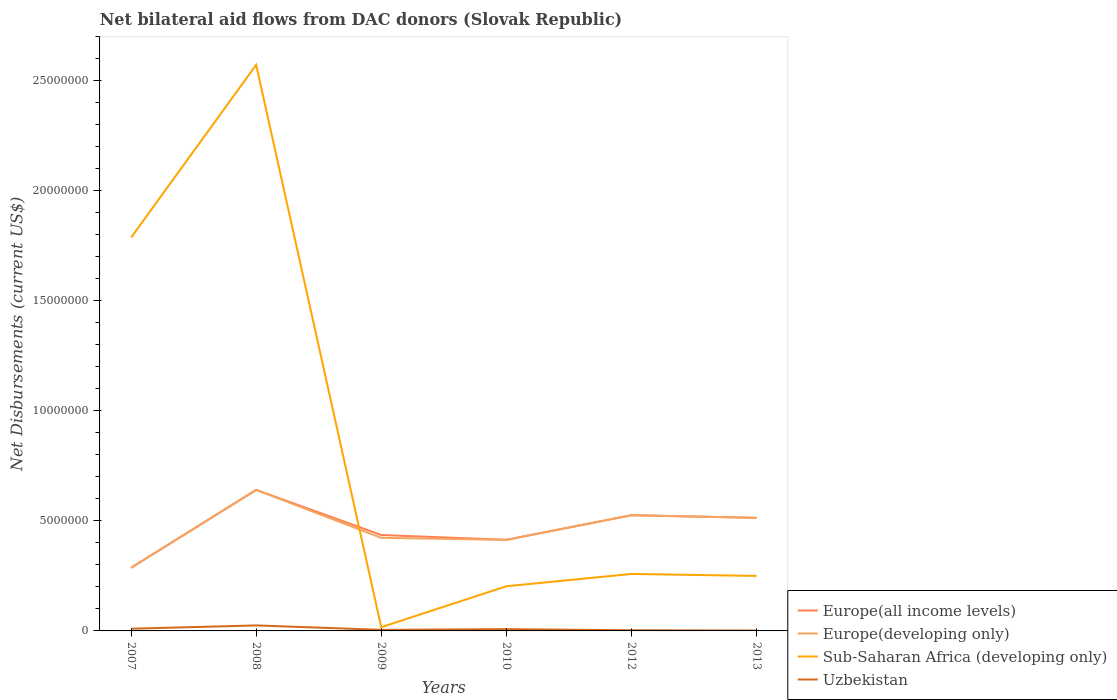How many different coloured lines are there?
Your answer should be compact. 4. Is the number of lines equal to the number of legend labels?
Your response must be concise. Yes. Across all years, what is the maximum net bilateral aid flows in Sub-Saharan Africa (developing only)?
Give a very brief answer. 1.70e+05. What is the difference between the highest and the second highest net bilateral aid flows in Europe(all income levels)?
Your answer should be very brief. 3.54e+06. What is the difference between the highest and the lowest net bilateral aid flows in Uzbekistan?
Offer a very short reply. 2. Is the net bilateral aid flows in Uzbekistan strictly greater than the net bilateral aid flows in Europe(developing only) over the years?
Offer a very short reply. Yes. How many lines are there?
Offer a very short reply. 4. What is the difference between two consecutive major ticks on the Y-axis?
Provide a short and direct response. 5.00e+06. Does the graph contain any zero values?
Give a very brief answer. No. What is the title of the graph?
Your response must be concise. Net bilateral aid flows from DAC donors (Slovak Republic). What is the label or title of the X-axis?
Keep it short and to the point. Years. What is the label or title of the Y-axis?
Your answer should be compact. Net Disbursements (current US$). What is the Net Disbursements (current US$) in Europe(all income levels) in 2007?
Provide a short and direct response. 2.87e+06. What is the Net Disbursements (current US$) of Europe(developing only) in 2007?
Keep it short and to the point. 2.87e+06. What is the Net Disbursements (current US$) of Sub-Saharan Africa (developing only) in 2007?
Give a very brief answer. 1.79e+07. What is the Net Disbursements (current US$) in Europe(all income levels) in 2008?
Ensure brevity in your answer.  6.41e+06. What is the Net Disbursements (current US$) in Europe(developing only) in 2008?
Ensure brevity in your answer.  6.41e+06. What is the Net Disbursements (current US$) in Sub-Saharan Africa (developing only) in 2008?
Offer a very short reply. 2.57e+07. What is the Net Disbursements (current US$) in Europe(all income levels) in 2009?
Offer a terse response. 4.36e+06. What is the Net Disbursements (current US$) of Europe(developing only) in 2009?
Provide a succinct answer. 4.23e+06. What is the Net Disbursements (current US$) in Europe(all income levels) in 2010?
Make the answer very short. 4.14e+06. What is the Net Disbursements (current US$) in Europe(developing only) in 2010?
Provide a short and direct response. 4.14e+06. What is the Net Disbursements (current US$) in Sub-Saharan Africa (developing only) in 2010?
Offer a very short reply. 2.03e+06. What is the Net Disbursements (current US$) of Uzbekistan in 2010?
Keep it short and to the point. 8.00e+04. What is the Net Disbursements (current US$) of Europe(all income levels) in 2012?
Offer a terse response. 5.26e+06. What is the Net Disbursements (current US$) in Europe(developing only) in 2012?
Provide a short and direct response. 5.26e+06. What is the Net Disbursements (current US$) in Sub-Saharan Africa (developing only) in 2012?
Give a very brief answer. 2.59e+06. What is the Net Disbursements (current US$) of Uzbekistan in 2012?
Offer a very short reply. 3.00e+04. What is the Net Disbursements (current US$) of Europe(all income levels) in 2013?
Ensure brevity in your answer.  5.14e+06. What is the Net Disbursements (current US$) in Europe(developing only) in 2013?
Your response must be concise. 5.14e+06. What is the Net Disbursements (current US$) of Sub-Saharan Africa (developing only) in 2013?
Ensure brevity in your answer.  2.50e+06. Across all years, what is the maximum Net Disbursements (current US$) of Europe(all income levels)?
Offer a very short reply. 6.41e+06. Across all years, what is the maximum Net Disbursements (current US$) in Europe(developing only)?
Provide a succinct answer. 6.41e+06. Across all years, what is the maximum Net Disbursements (current US$) of Sub-Saharan Africa (developing only)?
Offer a terse response. 2.57e+07. Across all years, what is the minimum Net Disbursements (current US$) of Europe(all income levels)?
Ensure brevity in your answer.  2.87e+06. Across all years, what is the minimum Net Disbursements (current US$) of Europe(developing only)?
Offer a very short reply. 2.87e+06. What is the total Net Disbursements (current US$) in Europe(all income levels) in the graph?
Your answer should be compact. 2.82e+07. What is the total Net Disbursements (current US$) in Europe(developing only) in the graph?
Your answer should be very brief. 2.80e+07. What is the total Net Disbursements (current US$) of Sub-Saharan Africa (developing only) in the graph?
Give a very brief answer. 5.09e+07. What is the total Net Disbursements (current US$) of Uzbekistan in the graph?
Provide a succinct answer. 5.30e+05. What is the difference between the Net Disbursements (current US$) in Europe(all income levels) in 2007 and that in 2008?
Your answer should be compact. -3.54e+06. What is the difference between the Net Disbursements (current US$) of Europe(developing only) in 2007 and that in 2008?
Keep it short and to the point. -3.54e+06. What is the difference between the Net Disbursements (current US$) of Sub-Saharan Africa (developing only) in 2007 and that in 2008?
Provide a short and direct response. -7.85e+06. What is the difference between the Net Disbursements (current US$) in Europe(all income levels) in 2007 and that in 2009?
Make the answer very short. -1.49e+06. What is the difference between the Net Disbursements (current US$) in Europe(developing only) in 2007 and that in 2009?
Provide a short and direct response. -1.36e+06. What is the difference between the Net Disbursements (current US$) in Sub-Saharan Africa (developing only) in 2007 and that in 2009?
Provide a succinct answer. 1.77e+07. What is the difference between the Net Disbursements (current US$) of Europe(all income levels) in 2007 and that in 2010?
Offer a very short reply. -1.27e+06. What is the difference between the Net Disbursements (current US$) in Europe(developing only) in 2007 and that in 2010?
Offer a terse response. -1.27e+06. What is the difference between the Net Disbursements (current US$) of Sub-Saharan Africa (developing only) in 2007 and that in 2010?
Your answer should be very brief. 1.58e+07. What is the difference between the Net Disbursements (current US$) of Europe(all income levels) in 2007 and that in 2012?
Offer a very short reply. -2.39e+06. What is the difference between the Net Disbursements (current US$) of Europe(developing only) in 2007 and that in 2012?
Provide a short and direct response. -2.39e+06. What is the difference between the Net Disbursements (current US$) of Sub-Saharan Africa (developing only) in 2007 and that in 2012?
Your answer should be very brief. 1.53e+07. What is the difference between the Net Disbursements (current US$) in Uzbekistan in 2007 and that in 2012?
Ensure brevity in your answer.  7.00e+04. What is the difference between the Net Disbursements (current US$) of Europe(all income levels) in 2007 and that in 2013?
Provide a succinct answer. -2.27e+06. What is the difference between the Net Disbursements (current US$) in Europe(developing only) in 2007 and that in 2013?
Your response must be concise. -2.27e+06. What is the difference between the Net Disbursements (current US$) in Sub-Saharan Africa (developing only) in 2007 and that in 2013?
Offer a terse response. 1.54e+07. What is the difference between the Net Disbursements (current US$) in Uzbekistan in 2007 and that in 2013?
Make the answer very short. 8.00e+04. What is the difference between the Net Disbursements (current US$) in Europe(all income levels) in 2008 and that in 2009?
Keep it short and to the point. 2.05e+06. What is the difference between the Net Disbursements (current US$) in Europe(developing only) in 2008 and that in 2009?
Provide a succinct answer. 2.18e+06. What is the difference between the Net Disbursements (current US$) of Sub-Saharan Africa (developing only) in 2008 and that in 2009?
Make the answer very short. 2.56e+07. What is the difference between the Net Disbursements (current US$) in Uzbekistan in 2008 and that in 2009?
Provide a succinct answer. 2.00e+05. What is the difference between the Net Disbursements (current US$) in Europe(all income levels) in 2008 and that in 2010?
Offer a very short reply. 2.27e+06. What is the difference between the Net Disbursements (current US$) in Europe(developing only) in 2008 and that in 2010?
Your response must be concise. 2.27e+06. What is the difference between the Net Disbursements (current US$) of Sub-Saharan Africa (developing only) in 2008 and that in 2010?
Ensure brevity in your answer.  2.37e+07. What is the difference between the Net Disbursements (current US$) in Uzbekistan in 2008 and that in 2010?
Ensure brevity in your answer.  1.70e+05. What is the difference between the Net Disbursements (current US$) in Europe(all income levels) in 2008 and that in 2012?
Provide a succinct answer. 1.15e+06. What is the difference between the Net Disbursements (current US$) in Europe(developing only) in 2008 and that in 2012?
Offer a very short reply. 1.15e+06. What is the difference between the Net Disbursements (current US$) in Sub-Saharan Africa (developing only) in 2008 and that in 2012?
Your answer should be very brief. 2.31e+07. What is the difference between the Net Disbursements (current US$) in Uzbekistan in 2008 and that in 2012?
Keep it short and to the point. 2.20e+05. What is the difference between the Net Disbursements (current US$) of Europe(all income levels) in 2008 and that in 2013?
Make the answer very short. 1.27e+06. What is the difference between the Net Disbursements (current US$) in Europe(developing only) in 2008 and that in 2013?
Make the answer very short. 1.27e+06. What is the difference between the Net Disbursements (current US$) of Sub-Saharan Africa (developing only) in 2008 and that in 2013?
Offer a very short reply. 2.32e+07. What is the difference between the Net Disbursements (current US$) in Uzbekistan in 2008 and that in 2013?
Keep it short and to the point. 2.30e+05. What is the difference between the Net Disbursements (current US$) in Europe(developing only) in 2009 and that in 2010?
Your response must be concise. 9.00e+04. What is the difference between the Net Disbursements (current US$) of Sub-Saharan Africa (developing only) in 2009 and that in 2010?
Your answer should be very brief. -1.86e+06. What is the difference between the Net Disbursements (current US$) in Europe(all income levels) in 2009 and that in 2012?
Offer a terse response. -9.00e+05. What is the difference between the Net Disbursements (current US$) in Europe(developing only) in 2009 and that in 2012?
Provide a succinct answer. -1.03e+06. What is the difference between the Net Disbursements (current US$) in Sub-Saharan Africa (developing only) in 2009 and that in 2012?
Make the answer very short. -2.42e+06. What is the difference between the Net Disbursements (current US$) of Europe(all income levels) in 2009 and that in 2013?
Offer a very short reply. -7.80e+05. What is the difference between the Net Disbursements (current US$) in Europe(developing only) in 2009 and that in 2013?
Your response must be concise. -9.10e+05. What is the difference between the Net Disbursements (current US$) in Sub-Saharan Africa (developing only) in 2009 and that in 2013?
Your answer should be very brief. -2.33e+06. What is the difference between the Net Disbursements (current US$) of Europe(all income levels) in 2010 and that in 2012?
Provide a short and direct response. -1.12e+06. What is the difference between the Net Disbursements (current US$) in Europe(developing only) in 2010 and that in 2012?
Offer a very short reply. -1.12e+06. What is the difference between the Net Disbursements (current US$) of Sub-Saharan Africa (developing only) in 2010 and that in 2012?
Offer a very short reply. -5.60e+05. What is the difference between the Net Disbursements (current US$) in Europe(all income levels) in 2010 and that in 2013?
Offer a very short reply. -1.00e+06. What is the difference between the Net Disbursements (current US$) of Europe(developing only) in 2010 and that in 2013?
Provide a succinct answer. -1.00e+06. What is the difference between the Net Disbursements (current US$) of Sub-Saharan Africa (developing only) in 2010 and that in 2013?
Your answer should be compact. -4.70e+05. What is the difference between the Net Disbursements (current US$) in Europe(developing only) in 2012 and that in 2013?
Offer a very short reply. 1.20e+05. What is the difference between the Net Disbursements (current US$) in Sub-Saharan Africa (developing only) in 2012 and that in 2013?
Offer a very short reply. 9.00e+04. What is the difference between the Net Disbursements (current US$) of Uzbekistan in 2012 and that in 2013?
Make the answer very short. 10000. What is the difference between the Net Disbursements (current US$) in Europe(all income levels) in 2007 and the Net Disbursements (current US$) in Europe(developing only) in 2008?
Your response must be concise. -3.54e+06. What is the difference between the Net Disbursements (current US$) of Europe(all income levels) in 2007 and the Net Disbursements (current US$) of Sub-Saharan Africa (developing only) in 2008?
Your answer should be very brief. -2.29e+07. What is the difference between the Net Disbursements (current US$) of Europe(all income levels) in 2007 and the Net Disbursements (current US$) of Uzbekistan in 2008?
Offer a terse response. 2.62e+06. What is the difference between the Net Disbursements (current US$) of Europe(developing only) in 2007 and the Net Disbursements (current US$) of Sub-Saharan Africa (developing only) in 2008?
Your response must be concise. -2.29e+07. What is the difference between the Net Disbursements (current US$) of Europe(developing only) in 2007 and the Net Disbursements (current US$) of Uzbekistan in 2008?
Your answer should be very brief. 2.62e+06. What is the difference between the Net Disbursements (current US$) in Sub-Saharan Africa (developing only) in 2007 and the Net Disbursements (current US$) in Uzbekistan in 2008?
Offer a very short reply. 1.76e+07. What is the difference between the Net Disbursements (current US$) of Europe(all income levels) in 2007 and the Net Disbursements (current US$) of Europe(developing only) in 2009?
Provide a succinct answer. -1.36e+06. What is the difference between the Net Disbursements (current US$) of Europe(all income levels) in 2007 and the Net Disbursements (current US$) of Sub-Saharan Africa (developing only) in 2009?
Make the answer very short. 2.70e+06. What is the difference between the Net Disbursements (current US$) in Europe(all income levels) in 2007 and the Net Disbursements (current US$) in Uzbekistan in 2009?
Make the answer very short. 2.82e+06. What is the difference between the Net Disbursements (current US$) in Europe(developing only) in 2007 and the Net Disbursements (current US$) in Sub-Saharan Africa (developing only) in 2009?
Offer a very short reply. 2.70e+06. What is the difference between the Net Disbursements (current US$) of Europe(developing only) in 2007 and the Net Disbursements (current US$) of Uzbekistan in 2009?
Give a very brief answer. 2.82e+06. What is the difference between the Net Disbursements (current US$) of Sub-Saharan Africa (developing only) in 2007 and the Net Disbursements (current US$) of Uzbekistan in 2009?
Your answer should be very brief. 1.78e+07. What is the difference between the Net Disbursements (current US$) in Europe(all income levels) in 2007 and the Net Disbursements (current US$) in Europe(developing only) in 2010?
Your response must be concise. -1.27e+06. What is the difference between the Net Disbursements (current US$) of Europe(all income levels) in 2007 and the Net Disbursements (current US$) of Sub-Saharan Africa (developing only) in 2010?
Offer a terse response. 8.40e+05. What is the difference between the Net Disbursements (current US$) of Europe(all income levels) in 2007 and the Net Disbursements (current US$) of Uzbekistan in 2010?
Your answer should be very brief. 2.79e+06. What is the difference between the Net Disbursements (current US$) of Europe(developing only) in 2007 and the Net Disbursements (current US$) of Sub-Saharan Africa (developing only) in 2010?
Provide a short and direct response. 8.40e+05. What is the difference between the Net Disbursements (current US$) of Europe(developing only) in 2007 and the Net Disbursements (current US$) of Uzbekistan in 2010?
Provide a succinct answer. 2.79e+06. What is the difference between the Net Disbursements (current US$) in Sub-Saharan Africa (developing only) in 2007 and the Net Disbursements (current US$) in Uzbekistan in 2010?
Ensure brevity in your answer.  1.78e+07. What is the difference between the Net Disbursements (current US$) of Europe(all income levels) in 2007 and the Net Disbursements (current US$) of Europe(developing only) in 2012?
Your answer should be compact. -2.39e+06. What is the difference between the Net Disbursements (current US$) in Europe(all income levels) in 2007 and the Net Disbursements (current US$) in Sub-Saharan Africa (developing only) in 2012?
Keep it short and to the point. 2.80e+05. What is the difference between the Net Disbursements (current US$) in Europe(all income levels) in 2007 and the Net Disbursements (current US$) in Uzbekistan in 2012?
Offer a terse response. 2.84e+06. What is the difference between the Net Disbursements (current US$) in Europe(developing only) in 2007 and the Net Disbursements (current US$) in Sub-Saharan Africa (developing only) in 2012?
Keep it short and to the point. 2.80e+05. What is the difference between the Net Disbursements (current US$) of Europe(developing only) in 2007 and the Net Disbursements (current US$) of Uzbekistan in 2012?
Your response must be concise. 2.84e+06. What is the difference between the Net Disbursements (current US$) in Sub-Saharan Africa (developing only) in 2007 and the Net Disbursements (current US$) in Uzbekistan in 2012?
Your answer should be compact. 1.78e+07. What is the difference between the Net Disbursements (current US$) in Europe(all income levels) in 2007 and the Net Disbursements (current US$) in Europe(developing only) in 2013?
Make the answer very short. -2.27e+06. What is the difference between the Net Disbursements (current US$) of Europe(all income levels) in 2007 and the Net Disbursements (current US$) of Sub-Saharan Africa (developing only) in 2013?
Offer a very short reply. 3.70e+05. What is the difference between the Net Disbursements (current US$) in Europe(all income levels) in 2007 and the Net Disbursements (current US$) in Uzbekistan in 2013?
Ensure brevity in your answer.  2.85e+06. What is the difference between the Net Disbursements (current US$) of Europe(developing only) in 2007 and the Net Disbursements (current US$) of Sub-Saharan Africa (developing only) in 2013?
Ensure brevity in your answer.  3.70e+05. What is the difference between the Net Disbursements (current US$) of Europe(developing only) in 2007 and the Net Disbursements (current US$) of Uzbekistan in 2013?
Keep it short and to the point. 2.85e+06. What is the difference between the Net Disbursements (current US$) of Sub-Saharan Africa (developing only) in 2007 and the Net Disbursements (current US$) of Uzbekistan in 2013?
Your answer should be compact. 1.79e+07. What is the difference between the Net Disbursements (current US$) of Europe(all income levels) in 2008 and the Net Disbursements (current US$) of Europe(developing only) in 2009?
Give a very brief answer. 2.18e+06. What is the difference between the Net Disbursements (current US$) in Europe(all income levels) in 2008 and the Net Disbursements (current US$) in Sub-Saharan Africa (developing only) in 2009?
Your answer should be very brief. 6.24e+06. What is the difference between the Net Disbursements (current US$) in Europe(all income levels) in 2008 and the Net Disbursements (current US$) in Uzbekistan in 2009?
Your answer should be compact. 6.36e+06. What is the difference between the Net Disbursements (current US$) in Europe(developing only) in 2008 and the Net Disbursements (current US$) in Sub-Saharan Africa (developing only) in 2009?
Provide a succinct answer. 6.24e+06. What is the difference between the Net Disbursements (current US$) in Europe(developing only) in 2008 and the Net Disbursements (current US$) in Uzbekistan in 2009?
Provide a succinct answer. 6.36e+06. What is the difference between the Net Disbursements (current US$) of Sub-Saharan Africa (developing only) in 2008 and the Net Disbursements (current US$) of Uzbekistan in 2009?
Give a very brief answer. 2.57e+07. What is the difference between the Net Disbursements (current US$) in Europe(all income levels) in 2008 and the Net Disbursements (current US$) in Europe(developing only) in 2010?
Your answer should be very brief. 2.27e+06. What is the difference between the Net Disbursements (current US$) in Europe(all income levels) in 2008 and the Net Disbursements (current US$) in Sub-Saharan Africa (developing only) in 2010?
Give a very brief answer. 4.38e+06. What is the difference between the Net Disbursements (current US$) in Europe(all income levels) in 2008 and the Net Disbursements (current US$) in Uzbekistan in 2010?
Your response must be concise. 6.33e+06. What is the difference between the Net Disbursements (current US$) in Europe(developing only) in 2008 and the Net Disbursements (current US$) in Sub-Saharan Africa (developing only) in 2010?
Offer a very short reply. 4.38e+06. What is the difference between the Net Disbursements (current US$) of Europe(developing only) in 2008 and the Net Disbursements (current US$) of Uzbekistan in 2010?
Keep it short and to the point. 6.33e+06. What is the difference between the Net Disbursements (current US$) of Sub-Saharan Africa (developing only) in 2008 and the Net Disbursements (current US$) of Uzbekistan in 2010?
Keep it short and to the point. 2.56e+07. What is the difference between the Net Disbursements (current US$) of Europe(all income levels) in 2008 and the Net Disbursements (current US$) of Europe(developing only) in 2012?
Make the answer very short. 1.15e+06. What is the difference between the Net Disbursements (current US$) of Europe(all income levels) in 2008 and the Net Disbursements (current US$) of Sub-Saharan Africa (developing only) in 2012?
Keep it short and to the point. 3.82e+06. What is the difference between the Net Disbursements (current US$) of Europe(all income levels) in 2008 and the Net Disbursements (current US$) of Uzbekistan in 2012?
Your answer should be very brief. 6.38e+06. What is the difference between the Net Disbursements (current US$) of Europe(developing only) in 2008 and the Net Disbursements (current US$) of Sub-Saharan Africa (developing only) in 2012?
Keep it short and to the point. 3.82e+06. What is the difference between the Net Disbursements (current US$) of Europe(developing only) in 2008 and the Net Disbursements (current US$) of Uzbekistan in 2012?
Ensure brevity in your answer.  6.38e+06. What is the difference between the Net Disbursements (current US$) of Sub-Saharan Africa (developing only) in 2008 and the Net Disbursements (current US$) of Uzbekistan in 2012?
Make the answer very short. 2.57e+07. What is the difference between the Net Disbursements (current US$) in Europe(all income levels) in 2008 and the Net Disbursements (current US$) in Europe(developing only) in 2013?
Ensure brevity in your answer.  1.27e+06. What is the difference between the Net Disbursements (current US$) in Europe(all income levels) in 2008 and the Net Disbursements (current US$) in Sub-Saharan Africa (developing only) in 2013?
Make the answer very short. 3.91e+06. What is the difference between the Net Disbursements (current US$) of Europe(all income levels) in 2008 and the Net Disbursements (current US$) of Uzbekistan in 2013?
Your response must be concise. 6.39e+06. What is the difference between the Net Disbursements (current US$) of Europe(developing only) in 2008 and the Net Disbursements (current US$) of Sub-Saharan Africa (developing only) in 2013?
Offer a very short reply. 3.91e+06. What is the difference between the Net Disbursements (current US$) of Europe(developing only) in 2008 and the Net Disbursements (current US$) of Uzbekistan in 2013?
Give a very brief answer. 6.39e+06. What is the difference between the Net Disbursements (current US$) of Sub-Saharan Africa (developing only) in 2008 and the Net Disbursements (current US$) of Uzbekistan in 2013?
Give a very brief answer. 2.57e+07. What is the difference between the Net Disbursements (current US$) in Europe(all income levels) in 2009 and the Net Disbursements (current US$) in Europe(developing only) in 2010?
Offer a very short reply. 2.20e+05. What is the difference between the Net Disbursements (current US$) of Europe(all income levels) in 2009 and the Net Disbursements (current US$) of Sub-Saharan Africa (developing only) in 2010?
Provide a short and direct response. 2.33e+06. What is the difference between the Net Disbursements (current US$) in Europe(all income levels) in 2009 and the Net Disbursements (current US$) in Uzbekistan in 2010?
Your response must be concise. 4.28e+06. What is the difference between the Net Disbursements (current US$) in Europe(developing only) in 2009 and the Net Disbursements (current US$) in Sub-Saharan Africa (developing only) in 2010?
Give a very brief answer. 2.20e+06. What is the difference between the Net Disbursements (current US$) of Europe(developing only) in 2009 and the Net Disbursements (current US$) of Uzbekistan in 2010?
Provide a short and direct response. 4.15e+06. What is the difference between the Net Disbursements (current US$) of Sub-Saharan Africa (developing only) in 2009 and the Net Disbursements (current US$) of Uzbekistan in 2010?
Offer a very short reply. 9.00e+04. What is the difference between the Net Disbursements (current US$) in Europe(all income levels) in 2009 and the Net Disbursements (current US$) in Europe(developing only) in 2012?
Give a very brief answer. -9.00e+05. What is the difference between the Net Disbursements (current US$) in Europe(all income levels) in 2009 and the Net Disbursements (current US$) in Sub-Saharan Africa (developing only) in 2012?
Offer a terse response. 1.77e+06. What is the difference between the Net Disbursements (current US$) of Europe(all income levels) in 2009 and the Net Disbursements (current US$) of Uzbekistan in 2012?
Make the answer very short. 4.33e+06. What is the difference between the Net Disbursements (current US$) of Europe(developing only) in 2009 and the Net Disbursements (current US$) of Sub-Saharan Africa (developing only) in 2012?
Make the answer very short. 1.64e+06. What is the difference between the Net Disbursements (current US$) of Europe(developing only) in 2009 and the Net Disbursements (current US$) of Uzbekistan in 2012?
Offer a terse response. 4.20e+06. What is the difference between the Net Disbursements (current US$) in Sub-Saharan Africa (developing only) in 2009 and the Net Disbursements (current US$) in Uzbekistan in 2012?
Ensure brevity in your answer.  1.40e+05. What is the difference between the Net Disbursements (current US$) in Europe(all income levels) in 2009 and the Net Disbursements (current US$) in Europe(developing only) in 2013?
Your answer should be very brief. -7.80e+05. What is the difference between the Net Disbursements (current US$) in Europe(all income levels) in 2009 and the Net Disbursements (current US$) in Sub-Saharan Africa (developing only) in 2013?
Provide a short and direct response. 1.86e+06. What is the difference between the Net Disbursements (current US$) of Europe(all income levels) in 2009 and the Net Disbursements (current US$) of Uzbekistan in 2013?
Ensure brevity in your answer.  4.34e+06. What is the difference between the Net Disbursements (current US$) of Europe(developing only) in 2009 and the Net Disbursements (current US$) of Sub-Saharan Africa (developing only) in 2013?
Keep it short and to the point. 1.73e+06. What is the difference between the Net Disbursements (current US$) of Europe(developing only) in 2009 and the Net Disbursements (current US$) of Uzbekistan in 2013?
Provide a succinct answer. 4.21e+06. What is the difference between the Net Disbursements (current US$) in Europe(all income levels) in 2010 and the Net Disbursements (current US$) in Europe(developing only) in 2012?
Your answer should be compact. -1.12e+06. What is the difference between the Net Disbursements (current US$) of Europe(all income levels) in 2010 and the Net Disbursements (current US$) of Sub-Saharan Africa (developing only) in 2012?
Provide a succinct answer. 1.55e+06. What is the difference between the Net Disbursements (current US$) of Europe(all income levels) in 2010 and the Net Disbursements (current US$) of Uzbekistan in 2012?
Make the answer very short. 4.11e+06. What is the difference between the Net Disbursements (current US$) of Europe(developing only) in 2010 and the Net Disbursements (current US$) of Sub-Saharan Africa (developing only) in 2012?
Make the answer very short. 1.55e+06. What is the difference between the Net Disbursements (current US$) of Europe(developing only) in 2010 and the Net Disbursements (current US$) of Uzbekistan in 2012?
Offer a terse response. 4.11e+06. What is the difference between the Net Disbursements (current US$) of Sub-Saharan Africa (developing only) in 2010 and the Net Disbursements (current US$) of Uzbekistan in 2012?
Provide a succinct answer. 2.00e+06. What is the difference between the Net Disbursements (current US$) in Europe(all income levels) in 2010 and the Net Disbursements (current US$) in Sub-Saharan Africa (developing only) in 2013?
Make the answer very short. 1.64e+06. What is the difference between the Net Disbursements (current US$) in Europe(all income levels) in 2010 and the Net Disbursements (current US$) in Uzbekistan in 2013?
Your response must be concise. 4.12e+06. What is the difference between the Net Disbursements (current US$) of Europe(developing only) in 2010 and the Net Disbursements (current US$) of Sub-Saharan Africa (developing only) in 2013?
Ensure brevity in your answer.  1.64e+06. What is the difference between the Net Disbursements (current US$) in Europe(developing only) in 2010 and the Net Disbursements (current US$) in Uzbekistan in 2013?
Provide a succinct answer. 4.12e+06. What is the difference between the Net Disbursements (current US$) in Sub-Saharan Africa (developing only) in 2010 and the Net Disbursements (current US$) in Uzbekistan in 2013?
Make the answer very short. 2.01e+06. What is the difference between the Net Disbursements (current US$) of Europe(all income levels) in 2012 and the Net Disbursements (current US$) of Europe(developing only) in 2013?
Keep it short and to the point. 1.20e+05. What is the difference between the Net Disbursements (current US$) of Europe(all income levels) in 2012 and the Net Disbursements (current US$) of Sub-Saharan Africa (developing only) in 2013?
Offer a terse response. 2.76e+06. What is the difference between the Net Disbursements (current US$) in Europe(all income levels) in 2012 and the Net Disbursements (current US$) in Uzbekistan in 2013?
Make the answer very short. 5.24e+06. What is the difference between the Net Disbursements (current US$) in Europe(developing only) in 2012 and the Net Disbursements (current US$) in Sub-Saharan Africa (developing only) in 2013?
Your answer should be compact. 2.76e+06. What is the difference between the Net Disbursements (current US$) in Europe(developing only) in 2012 and the Net Disbursements (current US$) in Uzbekistan in 2013?
Keep it short and to the point. 5.24e+06. What is the difference between the Net Disbursements (current US$) in Sub-Saharan Africa (developing only) in 2012 and the Net Disbursements (current US$) in Uzbekistan in 2013?
Keep it short and to the point. 2.57e+06. What is the average Net Disbursements (current US$) in Europe(all income levels) per year?
Give a very brief answer. 4.70e+06. What is the average Net Disbursements (current US$) in Europe(developing only) per year?
Ensure brevity in your answer.  4.68e+06. What is the average Net Disbursements (current US$) in Sub-Saharan Africa (developing only) per year?
Your response must be concise. 8.48e+06. What is the average Net Disbursements (current US$) in Uzbekistan per year?
Keep it short and to the point. 8.83e+04. In the year 2007, what is the difference between the Net Disbursements (current US$) of Europe(all income levels) and Net Disbursements (current US$) of Europe(developing only)?
Provide a succinct answer. 0. In the year 2007, what is the difference between the Net Disbursements (current US$) in Europe(all income levels) and Net Disbursements (current US$) in Sub-Saharan Africa (developing only)?
Provide a short and direct response. -1.50e+07. In the year 2007, what is the difference between the Net Disbursements (current US$) in Europe(all income levels) and Net Disbursements (current US$) in Uzbekistan?
Provide a succinct answer. 2.77e+06. In the year 2007, what is the difference between the Net Disbursements (current US$) of Europe(developing only) and Net Disbursements (current US$) of Sub-Saharan Africa (developing only)?
Provide a short and direct response. -1.50e+07. In the year 2007, what is the difference between the Net Disbursements (current US$) in Europe(developing only) and Net Disbursements (current US$) in Uzbekistan?
Ensure brevity in your answer.  2.77e+06. In the year 2007, what is the difference between the Net Disbursements (current US$) in Sub-Saharan Africa (developing only) and Net Disbursements (current US$) in Uzbekistan?
Keep it short and to the point. 1.78e+07. In the year 2008, what is the difference between the Net Disbursements (current US$) of Europe(all income levels) and Net Disbursements (current US$) of Sub-Saharan Africa (developing only)?
Your answer should be very brief. -1.93e+07. In the year 2008, what is the difference between the Net Disbursements (current US$) of Europe(all income levels) and Net Disbursements (current US$) of Uzbekistan?
Offer a terse response. 6.16e+06. In the year 2008, what is the difference between the Net Disbursements (current US$) of Europe(developing only) and Net Disbursements (current US$) of Sub-Saharan Africa (developing only)?
Keep it short and to the point. -1.93e+07. In the year 2008, what is the difference between the Net Disbursements (current US$) in Europe(developing only) and Net Disbursements (current US$) in Uzbekistan?
Make the answer very short. 6.16e+06. In the year 2008, what is the difference between the Net Disbursements (current US$) of Sub-Saharan Africa (developing only) and Net Disbursements (current US$) of Uzbekistan?
Your answer should be compact. 2.55e+07. In the year 2009, what is the difference between the Net Disbursements (current US$) in Europe(all income levels) and Net Disbursements (current US$) in Sub-Saharan Africa (developing only)?
Offer a very short reply. 4.19e+06. In the year 2009, what is the difference between the Net Disbursements (current US$) of Europe(all income levels) and Net Disbursements (current US$) of Uzbekistan?
Provide a short and direct response. 4.31e+06. In the year 2009, what is the difference between the Net Disbursements (current US$) in Europe(developing only) and Net Disbursements (current US$) in Sub-Saharan Africa (developing only)?
Provide a short and direct response. 4.06e+06. In the year 2009, what is the difference between the Net Disbursements (current US$) of Europe(developing only) and Net Disbursements (current US$) of Uzbekistan?
Keep it short and to the point. 4.18e+06. In the year 2010, what is the difference between the Net Disbursements (current US$) in Europe(all income levels) and Net Disbursements (current US$) in Europe(developing only)?
Offer a very short reply. 0. In the year 2010, what is the difference between the Net Disbursements (current US$) in Europe(all income levels) and Net Disbursements (current US$) in Sub-Saharan Africa (developing only)?
Offer a terse response. 2.11e+06. In the year 2010, what is the difference between the Net Disbursements (current US$) in Europe(all income levels) and Net Disbursements (current US$) in Uzbekistan?
Keep it short and to the point. 4.06e+06. In the year 2010, what is the difference between the Net Disbursements (current US$) in Europe(developing only) and Net Disbursements (current US$) in Sub-Saharan Africa (developing only)?
Make the answer very short. 2.11e+06. In the year 2010, what is the difference between the Net Disbursements (current US$) in Europe(developing only) and Net Disbursements (current US$) in Uzbekistan?
Give a very brief answer. 4.06e+06. In the year 2010, what is the difference between the Net Disbursements (current US$) in Sub-Saharan Africa (developing only) and Net Disbursements (current US$) in Uzbekistan?
Make the answer very short. 1.95e+06. In the year 2012, what is the difference between the Net Disbursements (current US$) in Europe(all income levels) and Net Disbursements (current US$) in Sub-Saharan Africa (developing only)?
Make the answer very short. 2.67e+06. In the year 2012, what is the difference between the Net Disbursements (current US$) in Europe(all income levels) and Net Disbursements (current US$) in Uzbekistan?
Give a very brief answer. 5.23e+06. In the year 2012, what is the difference between the Net Disbursements (current US$) of Europe(developing only) and Net Disbursements (current US$) of Sub-Saharan Africa (developing only)?
Your answer should be compact. 2.67e+06. In the year 2012, what is the difference between the Net Disbursements (current US$) of Europe(developing only) and Net Disbursements (current US$) of Uzbekistan?
Your answer should be very brief. 5.23e+06. In the year 2012, what is the difference between the Net Disbursements (current US$) of Sub-Saharan Africa (developing only) and Net Disbursements (current US$) of Uzbekistan?
Your answer should be compact. 2.56e+06. In the year 2013, what is the difference between the Net Disbursements (current US$) in Europe(all income levels) and Net Disbursements (current US$) in Europe(developing only)?
Give a very brief answer. 0. In the year 2013, what is the difference between the Net Disbursements (current US$) in Europe(all income levels) and Net Disbursements (current US$) in Sub-Saharan Africa (developing only)?
Your answer should be very brief. 2.64e+06. In the year 2013, what is the difference between the Net Disbursements (current US$) of Europe(all income levels) and Net Disbursements (current US$) of Uzbekistan?
Keep it short and to the point. 5.12e+06. In the year 2013, what is the difference between the Net Disbursements (current US$) of Europe(developing only) and Net Disbursements (current US$) of Sub-Saharan Africa (developing only)?
Keep it short and to the point. 2.64e+06. In the year 2013, what is the difference between the Net Disbursements (current US$) of Europe(developing only) and Net Disbursements (current US$) of Uzbekistan?
Ensure brevity in your answer.  5.12e+06. In the year 2013, what is the difference between the Net Disbursements (current US$) of Sub-Saharan Africa (developing only) and Net Disbursements (current US$) of Uzbekistan?
Provide a succinct answer. 2.48e+06. What is the ratio of the Net Disbursements (current US$) of Europe(all income levels) in 2007 to that in 2008?
Keep it short and to the point. 0.45. What is the ratio of the Net Disbursements (current US$) of Europe(developing only) in 2007 to that in 2008?
Provide a succinct answer. 0.45. What is the ratio of the Net Disbursements (current US$) in Sub-Saharan Africa (developing only) in 2007 to that in 2008?
Ensure brevity in your answer.  0.69. What is the ratio of the Net Disbursements (current US$) in Europe(all income levels) in 2007 to that in 2009?
Keep it short and to the point. 0.66. What is the ratio of the Net Disbursements (current US$) of Europe(developing only) in 2007 to that in 2009?
Your answer should be very brief. 0.68. What is the ratio of the Net Disbursements (current US$) of Sub-Saharan Africa (developing only) in 2007 to that in 2009?
Your answer should be very brief. 105.18. What is the ratio of the Net Disbursements (current US$) in Europe(all income levels) in 2007 to that in 2010?
Provide a succinct answer. 0.69. What is the ratio of the Net Disbursements (current US$) in Europe(developing only) in 2007 to that in 2010?
Make the answer very short. 0.69. What is the ratio of the Net Disbursements (current US$) in Sub-Saharan Africa (developing only) in 2007 to that in 2010?
Provide a succinct answer. 8.81. What is the ratio of the Net Disbursements (current US$) in Uzbekistan in 2007 to that in 2010?
Give a very brief answer. 1.25. What is the ratio of the Net Disbursements (current US$) in Europe(all income levels) in 2007 to that in 2012?
Provide a short and direct response. 0.55. What is the ratio of the Net Disbursements (current US$) of Europe(developing only) in 2007 to that in 2012?
Your response must be concise. 0.55. What is the ratio of the Net Disbursements (current US$) of Sub-Saharan Africa (developing only) in 2007 to that in 2012?
Provide a short and direct response. 6.9. What is the ratio of the Net Disbursements (current US$) of Europe(all income levels) in 2007 to that in 2013?
Your answer should be very brief. 0.56. What is the ratio of the Net Disbursements (current US$) in Europe(developing only) in 2007 to that in 2013?
Keep it short and to the point. 0.56. What is the ratio of the Net Disbursements (current US$) in Sub-Saharan Africa (developing only) in 2007 to that in 2013?
Make the answer very short. 7.15. What is the ratio of the Net Disbursements (current US$) in Europe(all income levels) in 2008 to that in 2009?
Offer a very short reply. 1.47. What is the ratio of the Net Disbursements (current US$) of Europe(developing only) in 2008 to that in 2009?
Your response must be concise. 1.52. What is the ratio of the Net Disbursements (current US$) in Sub-Saharan Africa (developing only) in 2008 to that in 2009?
Your answer should be compact. 151.35. What is the ratio of the Net Disbursements (current US$) in Uzbekistan in 2008 to that in 2009?
Your response must be concise. 5. What is the ratio of the Net Disbursements (current US$) in Europe(all income levels) in 2008 to that in 2010?
Make the answer very short. 1.55. What is the ratio of the Net Disbursements (current US$) in Europe(developing only) in 2008 to that in 2010?
Your answer should be compact. 1.55. What is the ratio of the Net Disbursements (current US$) in Sub-Saharan Africa (developing only) in 2008 to that in 2010?
Give a very brief answer. 12.67. What is the ratio of the Net Disbursements (current US$) in Uzbekistan in 2008 to that in 2010?
Offer a terse response. 3.12. What is the ratio of the Net Disbursements (current US$) in Europe(all income levels) in 2008 to that in 2012?
Keep it short and to the point. 1.22. What is the ratio of the Net Disbursements (current US$) of Europe(developing only) in 2008 to that in 2012?
Your answer should be very brief. 1.22. What is the ratio of the Net Disbursements (current US$) of Sub-Saharan Africa (developing only) in 2008 to that in 2012?
Ensure brevity in your answer.  9.93. What is the ratio of the Net Disbursements (current US$) of Uzbekistan in 2008 to that in 2012?
Offer a terse response. 8.33. What is the ratio of the Net Disbursements (current US$) of Europe(all income levels) in 2008 to that in 2013?
Provide a succinct answer. 1.25. What is the ratio of the Net Disbursements (current US$) of Europe(developing only) in 2008 to that in 2013?
Ensure brevity in your answer.  1.25. What is the ratio of the Net Disbursements (current US$) in Sub-Saharan Africa (developing only) in 2008 to that in 2013?
Keep it short and to the point. 10.29. What is the ratio of the Net Disbursements (current US$) of Uzbekistan in 2008 to that in 2013?
Ensure brevity in your answer.  12.5. What is the ratio of the Net Disbursements (current US$) of Europe(all income levels) in 2009 to that in 2010?
Your answer should be very brief. 1.05. What is the ratio of the Net Disbursements (current US$) of Europe(developing only) in 2009 to that in 2010?
Ensure brevity in your answer.  1.02. What is the ratio of the Net Disbursements (current US$) of Sub-Saharan Africa (developing only) in 2009 to that in 2010?
Ensure brevity in your answer.  0.08. What is the ratio of the Net Disbursements (current US$) of Europe(all income levels) in 2009 to that in 2012?
Your answer should be very brief. 0.83. What is the ratio of the Net Disbursements (current US$) in Europe(developing only) in 2009 to that in 2012?
Ensure brevity in your answer.  0.8. What is the ratio of the Net Disbursements (current US$) of Sub-Saharan Africa (developing only) in 2009 to that in 2012?
Ensure brevity in your answer.  0.07. What is the ratio of the Net Disbursements (current US$) of Europe(all income levels) in 2009 to that in 2013?
Your response must be concise. 0.85. What is the ratio of the Net Disbursements (current US$) of Europe(developing only) in 2009 to that in 2013?
Offer a terse response. 0.82. What is the ratio of the Net Disbursements (current US$) of Sub-Saharan Africa (developing only) in 2009 to that in 2013?
Offer a very short reply. 0.07. What is the ratio of the Net Disbursements (current US$) in Europe(all income levels) in 2010 to that in 2012?
Ensure brevity in your answer.  0.79. What is the ratio of the Net Disbursements (current US$) of Europe(developing only) in 2010 to that in 2012?
Your answer should be compact. 0.79. What is the ratio of the Net Disbursements (current US$) of Sub-Saharan Africa (developing only) in 2010 to that in 2012?
Give a very brief answer. 0.78. What is the ratio of the Net Disbursements (current US$) in Uzbekistan in 2010 to that in 2012?
Keep it short and to the point. 2.67. What is the ratio of the Net Disbursements (current US$) of Europe(all income levels) in 2010 to that in 2013?
Provide a short and direct response. 0.81. What is the ratio of the Net Disbursements (current US$) of Europe(developing only) in 2010 to that in 2013?
Give a very brief answer. 0.81. What is the ratio of the Net Disbursements (current US$) in Sub-Saharan Africa (developing only) in 2010 to that in 2013?
Give a very brief answer. 0.81. What is the ratio of the Net Disbursements (current US$) of Uzbekistan in 2010 to that in 2013?
Offer a terse response. 4. What is the ratio of the Net Disbursements (current US$) of Europe(all income levels) in 2012 to that in 2013?
Offer a very short reply. 1.02. What is the ratio of the Net Disbursements (current US$) in Europe(developing only) in 2012 to that in 2013?
Give a very brief answer. 1.02. What is the ratio of the Net Disbursements (current US$) in Sub-Saharan Africa (developing only) in 2012 to that in 2013?
Give a very brief answer. 1.04. What is the ratio of the Net Disbursements (current US$) in Uzbekistan in 2012 to that in 2013?
Offer a terse response. 1.5. What is the difference between the highest and the second highest Net Disbursements (current US$) of Europe(all income levels)?
Provide a short and direct response. 1.15e+06. What is the difference between the highest and the second highest Net Disbursements (current US$) of Europe(developing only)?
Keep it short and to the point. 1.15e+06. What is the difference between the highest and the second highest Net Disbursements (current US$) of Sub-Saharan Africa (developing only)?
Provide a succinct answer. 7.85e+06. What is the difference between the highest and the lowest Net Disbursements (current US$) of Europe(all income levels)?
Offer a very short reply. 3.54e+06. What is the difference between the highest and the lowest Net Disbursements (current US$) of Europe(developing only)?
Your response must be concise. 3.54e+06. What is the difference between the highest and the lowest Net Disbursements (current US$) in Sub-Saharan Africa (developing only)?
Keep it short and to the point. 2.56e+07. 